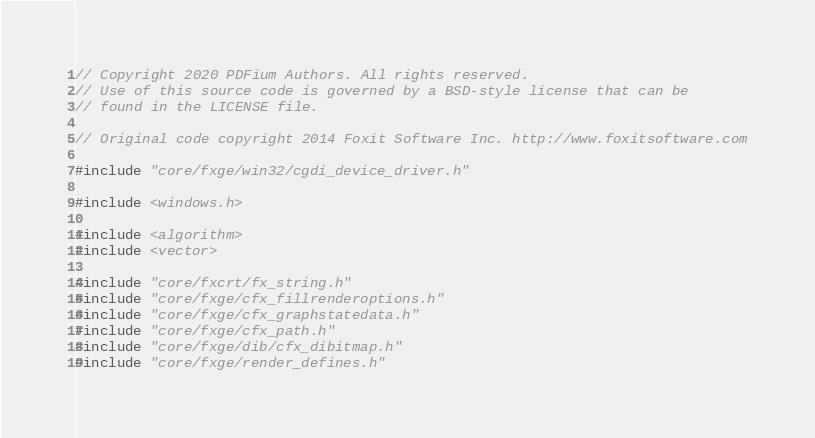<code> <loc_0><loc_0><loc_500><loc_500><_C++_>// Copyright 2020 PDFium Authors. All rights reserved.
// Use of this source code is governed by a BSD-style license that can be
// found in the LICENSE file.

// Original code copyright 2014 Foxit Software Inc. http://www.foxitsoftware.com

#include "core/fxge/win32/cgdi_device_driver.h"

#include <windows.h>

#include <algorithm>
#include <vector>

#include "core/fxcrt/fx_string.h"
#include "core/fxge/cfx_fillrenderoptions.h"
#include "core/fxge/cfx_graphstatedata.h"
#include "core/fxge/cfx_path.h"
#include "core/fxge/dib/cfx_dibitmap.h"
#include "core/fxge/render_defines.h"</code> 